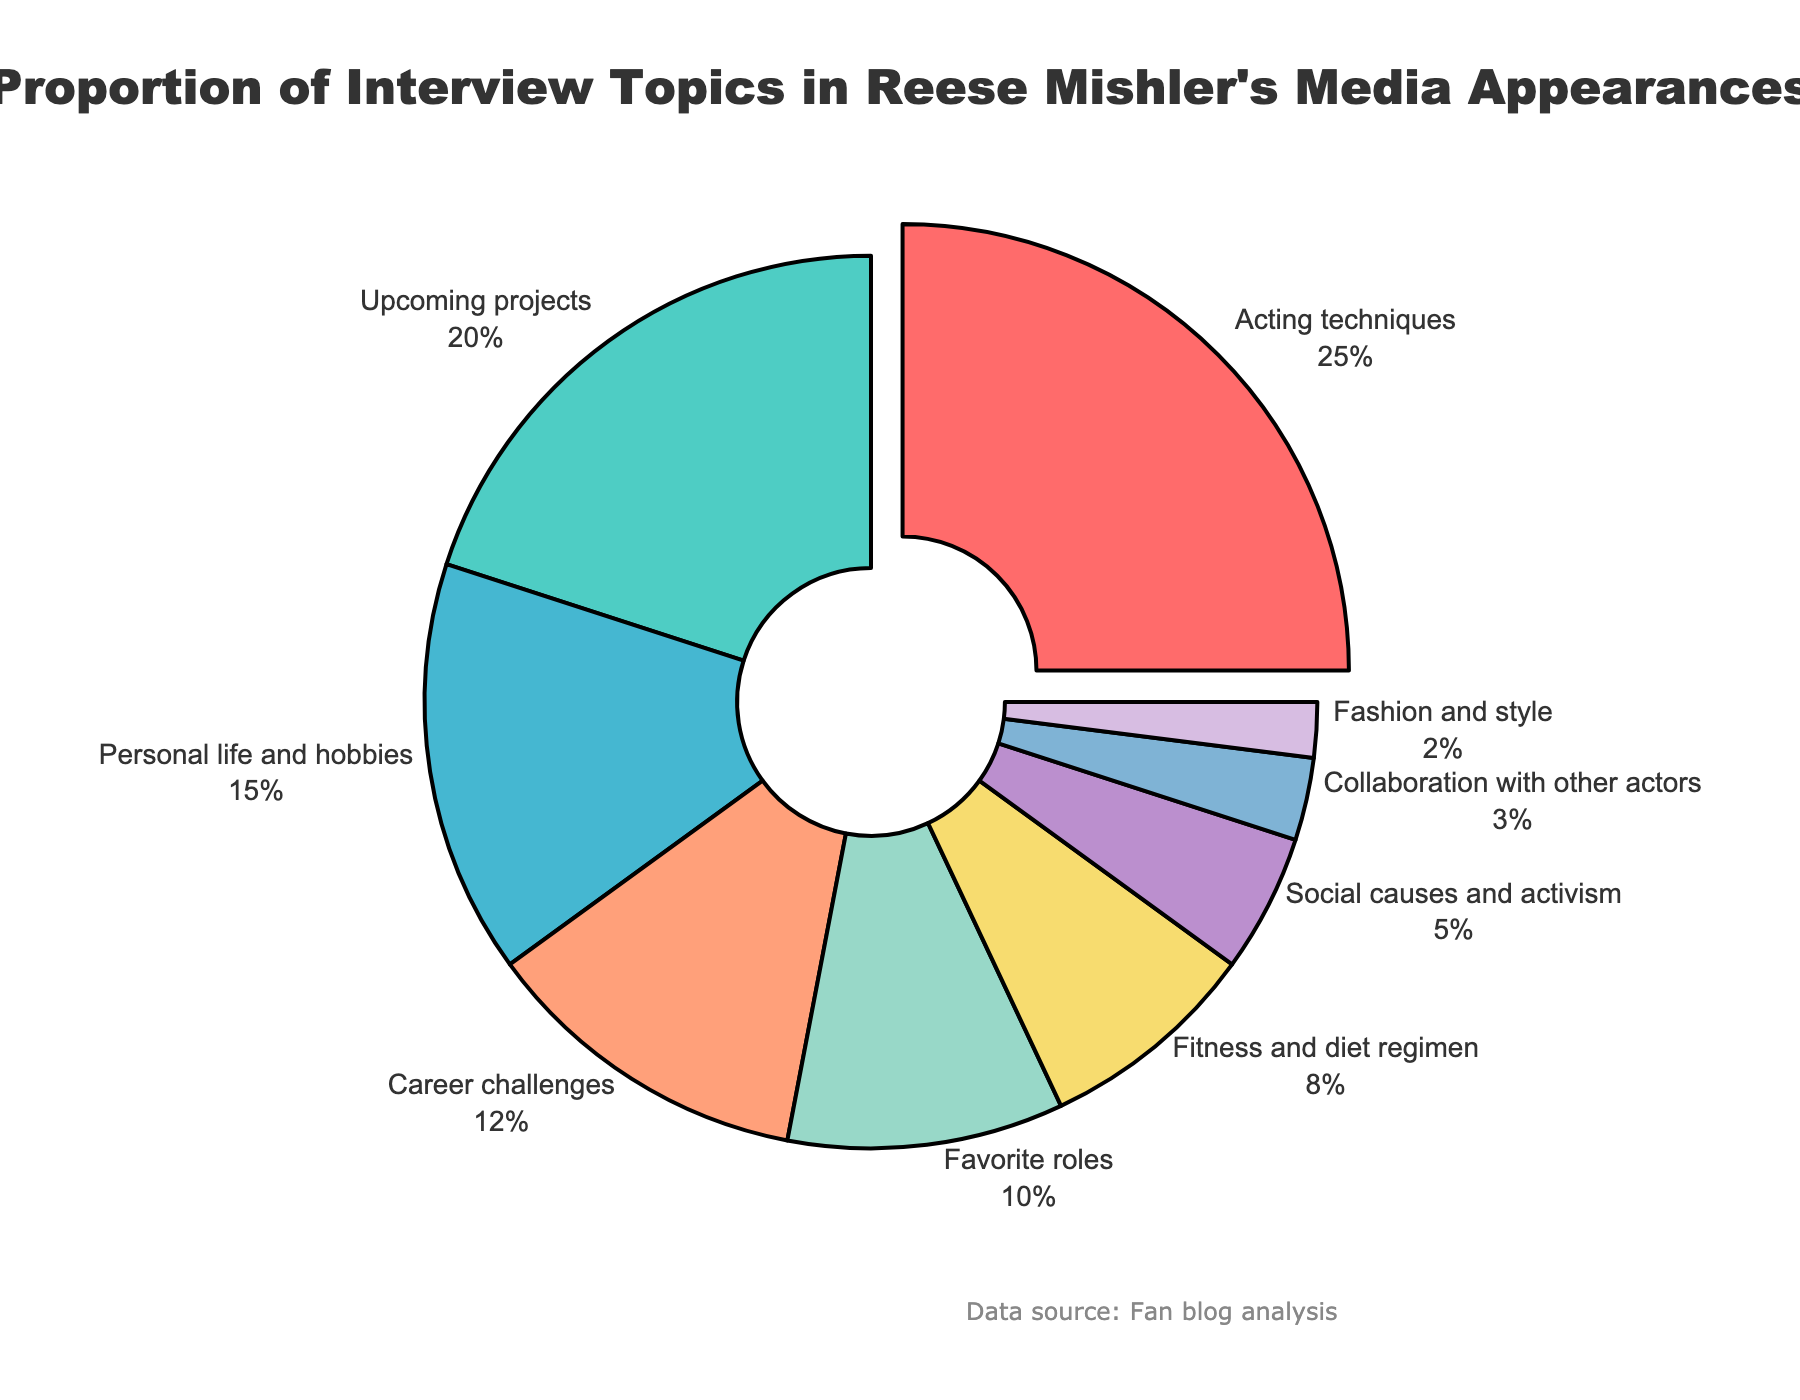Which topic is discussed the most in Reese Mishler’s media appearances? The topic with the largest percentage is labeled on the pie chart and is usually emphasized visually. In this case, it's "Acting techniques" with 25%.
Answer: Acting techniques Which color represents Reese's discussions about his upcoming projects? The color associated with "Upcoming projects" in the chart can be observed by matching the label to its corresponding segment. The segment "Upcoming projects" is represented using a blue-green color.
Answer: Blue-green What percentage of topics discussed are related to career challenges and fitness and diet regimen combined? Look at the chart to find the percentages for "Career challenges" (12%) and "Fitness and diet regimen" (8%). Adding them together gives 12% + 8% = 20%.
Answer: 20% Does Reese discuss his social causes and activism more or fashion and style more? Compare the percentages given for "Social causes and activism" (5%) and "Fashion and style" (2%). Since 5% is greater than 2%, Reese discusses his social causes and activism more.
Answer: Social causes and activism Identify the topics discussed that cumulatively make up at least 50% of Reese's interviews. Adding the percentages from the largest to smallest until the sum reaches or exceeds 50%, we get: "Acting techniques" (25%) + "Upcoming projects" (20%) = 45%, then "Personal life and hobbies" (15%) next brings the sum to 60%. So, the topics are "Acting techniques", "Upcoming projects", and "Personal life and hobbies".
Answer: Acting techniques, Upcoming projects, Personal life and hobbies Which topic is the least discussed in Reese Mishler’s media appearances and what percentage does it represent? Identify the slice with the smallest percentage on the pie chart, which is "Fashion and style" with 2%.
Answer: Fashion and style, 2% What is the difference in percentage between discussions about favorite roles and collaboration with other actors? Find the percentages for "Favorite roles" (10%) and "Collaboration with other actors" (3%). The difference is 10% - 3% = 7%.
Answer: 7% By how much does the percentage of discussions about Reese's acting techniques exceed those about his social causes and activism? Look at the chart to get the values: "Acting techniques" (25%) and "Social causes and activism" (5%). The difference is 25% - 5% = 20%.
Answer: 20% How many topics take up less than 10% each in Reese Mishler's media appearances? By looking at the chart, count the topics with segments less than 10%: "Fitness and diet regimen" (8%), "Social causes and activism" (5%), "Collaboration with other actors" (3%), and "Fashion and style" (2%). There are 4 topics.
Answer: 4 What is the total percentage of Reese's interviews focused on discussions not related to acting techniques or upcoming projects? Subtract the percentages of "Acting techniques" (25%) and "Upcoming projects" (20%) from 100%: 100% - (25% + 20%) = 55%.
Answer: 55% 